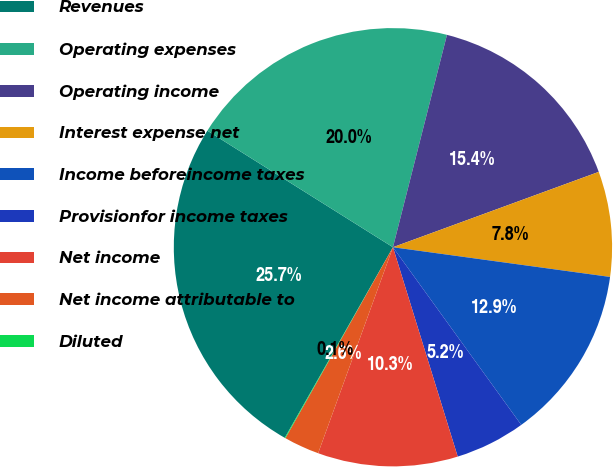Convert chart. <chart><loc_0><loc_0><loc_500><loc_500><pie_chart><fcel>Revenues<fcel>Operating expenses<fcel>Operating income<fcel>Interest expense net<fcel>Income beforeincome taxes<fcel>Provisionfor income taxes<fcel>Net income<fcel>Net income attributable to<fcel>Diluted<nl><fcel>25.71%<fcel>20.04%<fcel>15.45%<fcel>7.75%<fcel>12.88%<fcel>5.18%<fcel>10.32%<fcel>2.62%<fcel>0.05%<nl></chart> 